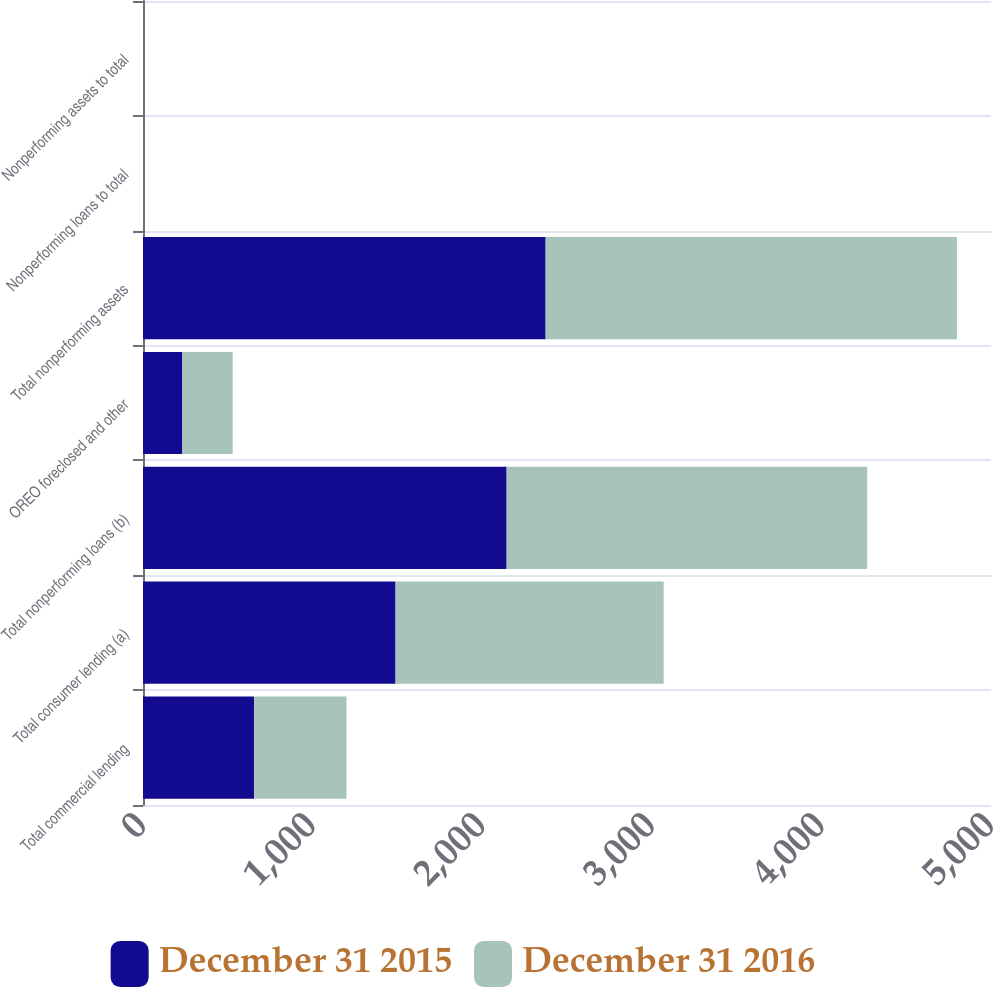Convert chart to OTSL. <chart><loc_0><loc_0><loc_500><loc_500><stacked_bar_chart><ecel><fcel>Total commercial lending<fcel>Total consumer lending (a)<fcel>Total nonperforming loans (b)<fcel>OREO foreclosed and other<fcel>Total nonperforming assets<fcel>Nonperforming loans to total<fcel>Nonperforming assets to total<nl><fcel>December 31 2015<fcel>655<fcel>1489<fcel>2144<fcel>230<fcel>2374<fcel>1.02<fcel>0.65<nl><fcel>December 31 2016<fcel>545<fcel>1581<fcel>2126<fcel>299<fcel>2425<fcel>1.03<fcel>0.68<nl></chart> 